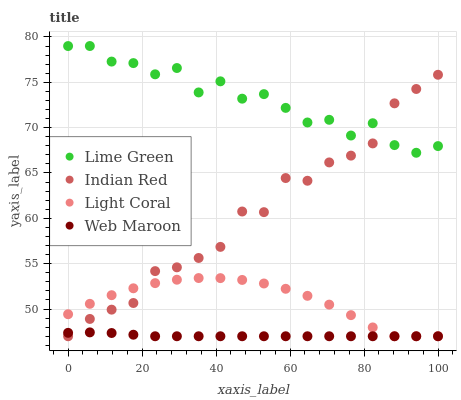Does Web Maroon have the minimum area under the curve?
Answer yes or no. Yes. Does Lime Green have the maximum area under the curve?
Answer yes or no. Yes. Does Lime Green have the minimum area under the curve?
Answer yes or no. No. Does Web Maroon have the maximum area under the curve?
Answer yes or no. No. Is Web Maroon the smoothest?
Answer yes or no. Yes. Is Lime Green the roughest?
Answer yes or no. Yes. Is Lime Green the smoothest?
Answer yes or no. No. Is Web Maroon the roughest?
Answer yes or no. No. Does Light Coral have the lowest value?
Answer yes or no. Yes. Does Lime Green have the lowest value?
Answer yes or no. No. Does Lime Green have the highest value?
Answer yes or no. Yes. Does Web Maroon have the highest value?
Answer yes or no. No. Is Light Coral less than Lime Green?
Answer yes or no. Yes. Is Lime Green greater than Web Maroon?
Answer yes or no. Yes. Does Light Coral intersect Indian Red?
Answer yes or no. Yes. Is Light Coral less than Indian Red?
Answer yes or no. No. Is Light Coral greater than Indian Red?
Answer yes or no. No. Does Light Coral intersect Lime Green?
Answer yes or no. No. 